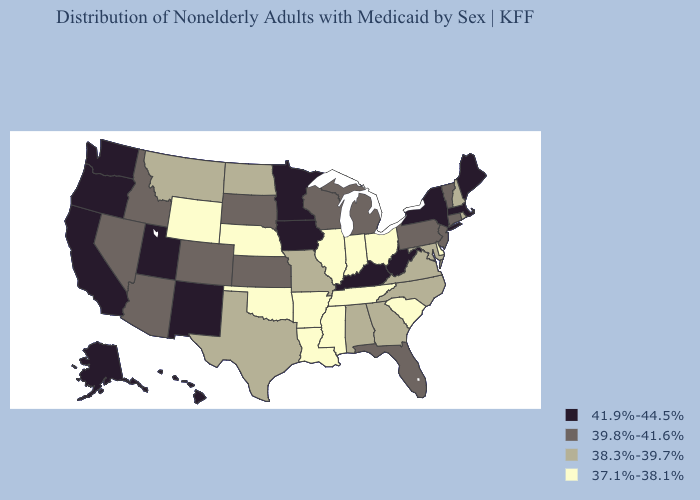Does California have the lowest value in the West?
Concise answer only. No. Does New York have the highest value in the Northeast?
Write a very short answer. Yes. What is the lowest value in states that border Nebraska?
Give a very brief answer. 37.1%-38.1%. What is the value of New York?
Write a very short answer. 41.9%-44.5%. What is the lowest value in the West?
Concise answer only. 37.1%-38.1%. What is the lowest value in states that border New Mexico?
Be succinct. 37.1%-38.1%. What is the value of Mississippi?
Be succinct. 37.1%-38.1%. Which states hav the highest value in the MidWest?
Be succinct. Iowa, Minnesota. What is the lowest value in the South?
Concise answer only. 37.1%-38.1%. Name the states that have a value in the range 41.9%-44.5%?
Write a very short answer. Alaska, California, Hawaii, Iowa, Kentucky, Maine, Massachusetts, Minnesota, New Mexico, New York, Oregon, Utah, Washington, West Virginia. Which states hav the highest value in the West?
Keep it brief. Alaska, California, Hawaii, New Mexico, Oregon, Utah, Washington. What is the value of Michigan?
Quick response, please. 39.8%-41.6%. Which states have the lowest value in the USA?
Be succinct. Arkansas, Delaware, Illinois, Indiana, Louisiana, Mississippi, Nebraska, Ohio, Oklahoma, South Carolina, Tennessee, Wyoming. Does Maine have the same value as South Dakota?
Give a very brief answer. No. Name the states that have a value in the range 37.1%-38.1%?
Give a very brief answer. Arkansas, Delaware, Illinois, Indiana, Louisiana, Mississippi, Nebraska, Ohio, Oklahoma, South Carolina, Tennessee, Wyoming. 